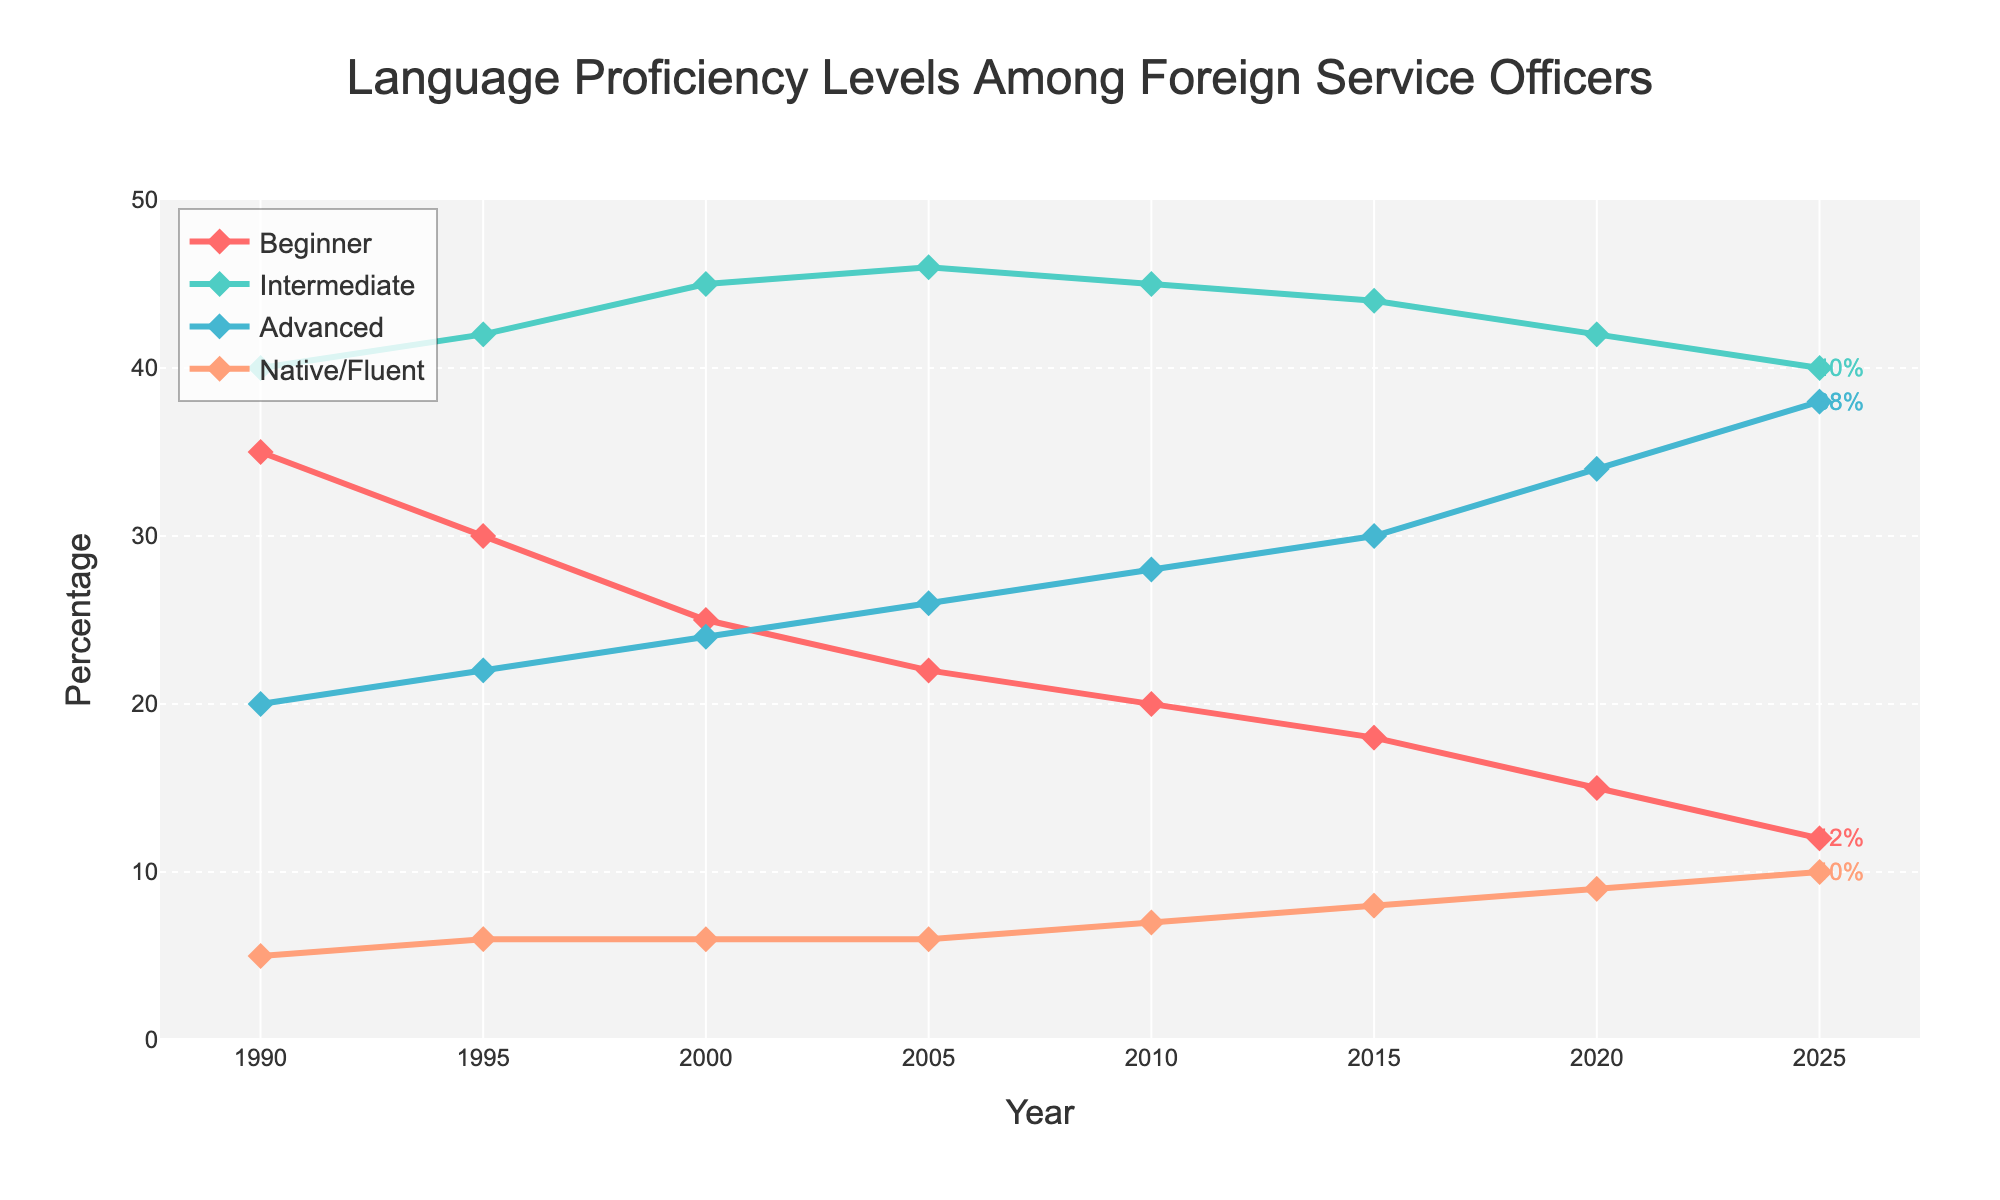What's the trend for Beginner proficiency levels from 1990 to 2025? The line for Beginner proficiency levels is consistently decreasing from 35% in 1990 to 12% in 2025. This indicates a downward trend over the years.
Answer: Decreasing In which year did the Advanced proficiency level first surpass the Intermediate level? Looking at the figure, Advanced proficiency surpasses Intermediate for the first time in 2025, where Advanced reached 38% and Intermediate was at 40%.
Answer: 2025 How much did the Native/Fluent proficiency level increase from 1990 to 2025? In 1990, the Native/Fluent proficiency was at 5%. In 2025, it reached 10%. The increase is the final value (10) minus the initial value (5), giving us 5%.
Answer: 5% Which proficiency level had the highest percentage in 2020? Observing the 2020 data point, the Intermediate proficiency level is the highest, marking 42% compared to other levels (Beginner: 15%, Advanced: 34%, Native/Fluent: 9%).
Answer: Intermediate What is the difference in percentage between Beginner and Advanced levels in 2010? The Beginner level is at 20% and the Advanced level is at 28% in 2010. The difference is calculated as 28% - 20% = 8%.
Answer: 8% Which proficiency level has shown the most consistent upward trend over the years? By evaluating the trends of all proficiency levels, the Native/Fluent level shows a consistent upward trend, starting from 5% in 1990 and increasing steadily to 10% in 2025.
Answer: Native/Fluent What is the combined percentage of Intermediate and Advanced levels in 2000? In the year 2000, Intermediate is at 45% and Advanced at 24%. Combining these gives 45% + 24% = 69%.
Answer: 69% How does the percentage of Beginner levels in 1995 compare to that in 2000? In 1995, the Beginner level is at 30% and in 2000, it is 25%. Comparing these, the level decreased by 5% (30% - 25%).
Answer: Decreased by 5% Which year saw the highest percentage for the Advanced proficiency level? Reviewing the chart, the highest percentage for the Advanced level is seen in 2025, where it reaches 38%.
Answer: 2025 What is the average percentage of the Native/Fluent proficiency level over the given period? To find the average, sum all the percentages from 1990 to 2025 (5 + 6 + 6 + 6 + 7 + 8 + 9 + 10 = 57) and divide by the number of years given (8). The average is 57 / 8 = 7.125.
Answer: 7.125 